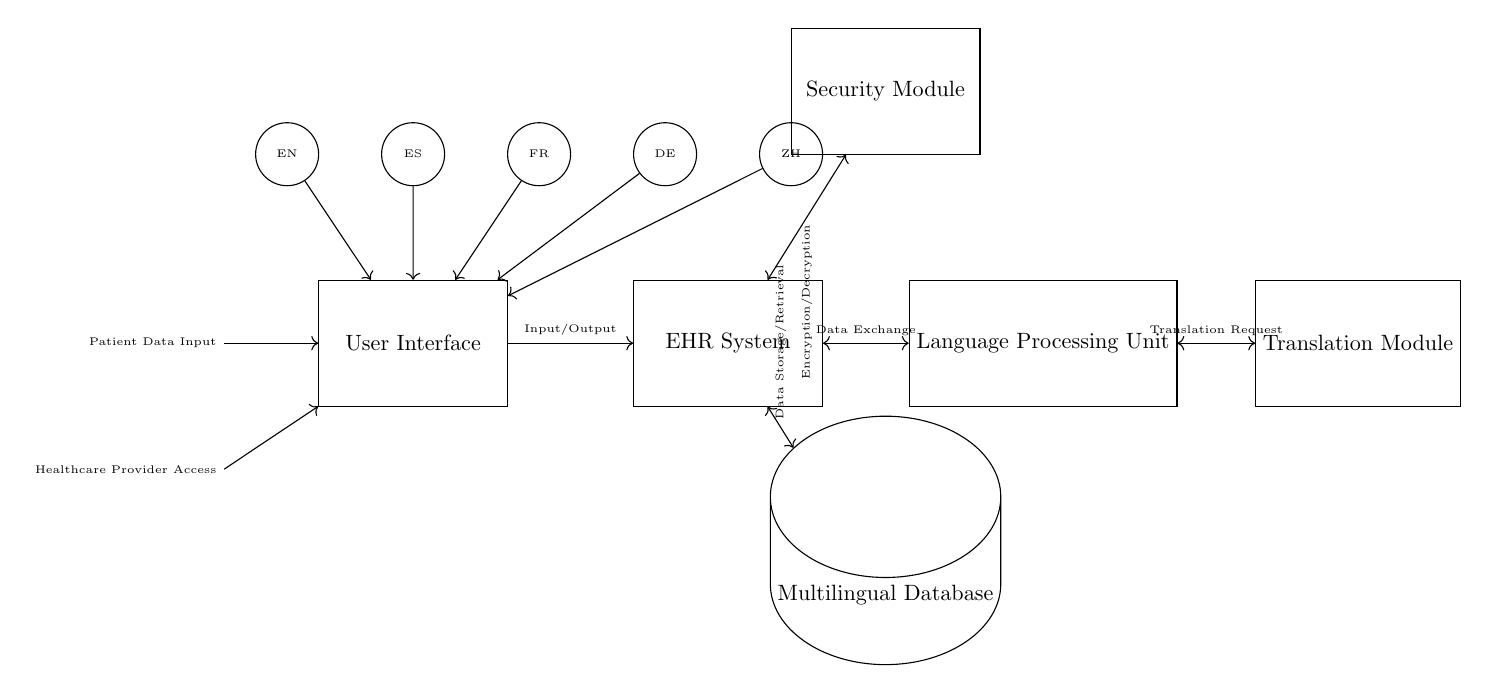What is the main component of this circuit? The main component depicted is the EHR System, which serves as the core of the patient data management system.
Answer: EHR System How many language processing units are present? There is one Language Processing Unit in the circuit, which is responsible for handling the different languages in patient data.
Answer: One What type of storage is used in this circuit? The circuit uses a Multilingual Database, which is specifically designed to store data in multiple languages.
Answer: Multilingual Database Which module handles security? The Security Module is responsible for encryption and decryption of patient data, ensuring secure access and storage.
Answer: Security Module What are the input sources for the User Interface? The input sources include Patient Data Input and Healthcare Provider Access, both of which interact with the User Interface.
Answer: Patient Data Input and Healthcare Provider Access Explain the flow of data between components. Data flows from Patient Data Input and Healthcare Provider Access to the User Interface, which then communicates with the EHR System. The EHR exchanges data with the Language Processing Unit and the Multilingual Database for storage and retrieval while also interacting with the Translation Module and Security Module.
Answer: From input sources to User Interface, to EHR, then to Language Processing Unit and Database, and interacts with Translation and Security Modules 